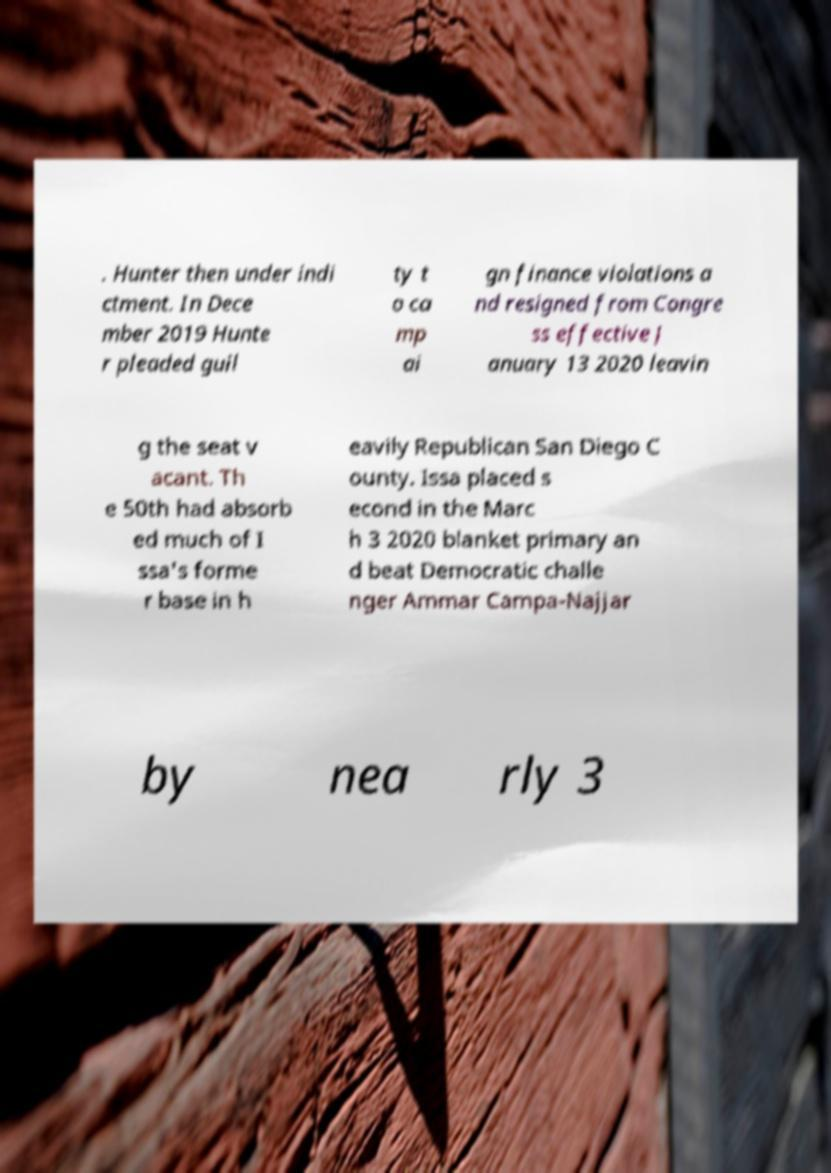I need the written content from this picture converted into text. Can you do that? . Hunter then under indi ctment. In Dece mber 2019 Hunte r pleaded guil ty t o ca mp ai gn finance violations a nd resigned from Congre ss effective J anuary 13 2020 leavin g the seat v acant. Th e 50th had absorb ed much of I ssa's forme r base in h eavily Republican San Diego C ounty. Issa placed s econd in the Marc h 3 2020 blanket primary an d beat Democratic challe nger Ammar Campa-Najjar by nea rly 3 